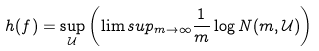<formula> <loc_0><loc_0><loc_500><loc_500>h ( f ) = \sup _ { \mathcal { U } } \left ( \lim s u p _ { m \to \infty } \frac { 1 } { m } \log N ( m , \mathcal { U } ) \right )</formula> 